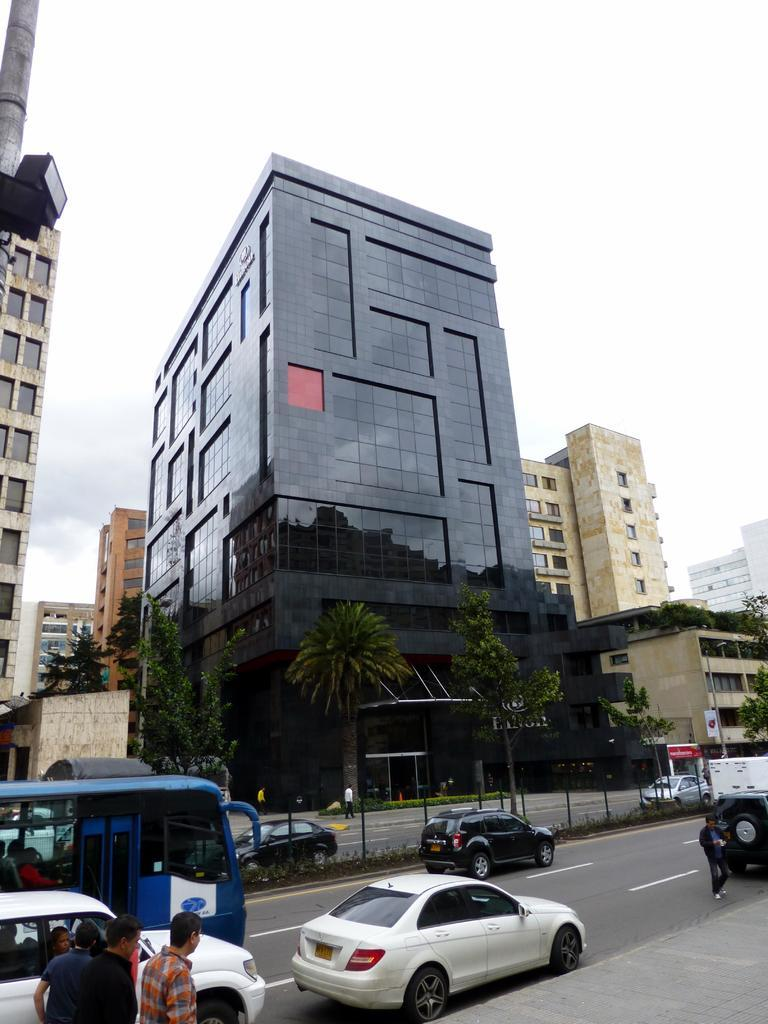What type of structures can be seen in the image? There are buildings in the image. What other natural elements are present in the image? There are trees in the image. What mode of transportation can be seen on the road in the image? There are vehicles on the road in the image. Are there any living beings visible in the image? Yes, there are people in the image. What are some man-made objects present in the image? There are poles and a sign board in the image. What architectural feature can be seen on the buildings in the image? There are windows in the image. What part of the natural environment is visible in the image? The sky is visible in the image. What type of pin can be seen holding up the rock in the image? There is no pin or rock present in the image. What kind of breakfast is being served in the image? There is no breakfast being served in the image. 